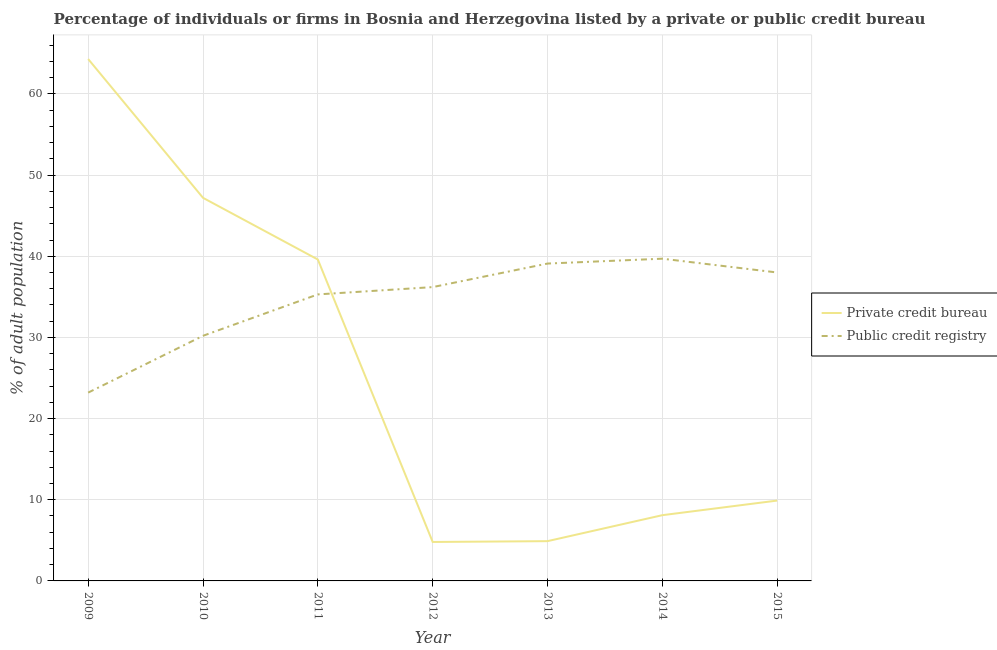How many different coloured lines are there?
Offer a terse response. 2. Does the line corresponding to percentage of firms listed by public credit bureau intersect with the line corresponding to percentage of firms listed by private credit bureau?
Offer a very short reply. Yes. What is the percentage of firms listed by private credit bureau in 2011?
Give a very brief answer. 39.6. Across all years, what is the maximum percentage of firms listed by public credit bureau?
Your answer should be very brief. 39.7. Across all years, what is the minimum percentage of firms listed by private credit bureau?
Your response must be concise. 4.8. In which year was the percentage of firms listed by private credit bureau minimum?
Your response must be concise. 2012. What is the total percentage of firms listed by public credit bureau in the graph?
Provide a succinct answer. 241.7. What is the difference between the percentage of firms listed by public credit bureau in 2009 and that in 2014?
Your response must be concise. -16.5. What is the difference between the percentage of firms listed by private credit bureau in 2015 and the percentage of firms listed by public credit bureau in 2012?
Provide a succinct answer. -26.3. What is the average percentage of firms listed by private credit bureau per year?
Provide a succinct answer. 25.54. In the year 2013, what is the difference between the percentage of firms listed by private credit bureau and percentage of firms listed by public credit bureau?
Keep it short and to the point. -34.2. In how many years, is the percentage of firms listed by public credit bureau greater than 8 %?
Keep it short and to the point. 7. What is the ratio of the percentage of firms listed by public credit bureau in 2010 to that in 2014?
Your response must be concise. 0.76. Is the percentage of firms listed by private credit bureau in 2009 less than that in 2011?
Ensure brevity in your answer.  No. Is the difference between the percentage of firms listed by private credit bureau in 2010 and 2011 greater than the difference between the percentage of firms listed by public credit bureau in 2010 and 2011?
Offer a terse response. Yes. What is the difference between the highest and the second highest percentage of firms listed by private credit bureau?
Give a very brief answer. 17.1. What is the difference between the highest and the lowest percentage of firms listed by public credit bureau?
Offer a terse response. 16.5. Is the percentage of firms listed by private credit bureau strictly greater than the percentage of firms listed by public credit bureau over the years?
Give a very brief answer. No. Is the percentage of firms listed by public credit bureau strictly less than the percentage of firms listed by private credit bureau over the years?
Give a very brief answer. No. How many years are there in the graph?
Give a very brief answer. 7. Are the values on the major ticks of Y-axis written in scientific E-notation?
Ensure brevity in your answer.  No. Does the graph contain any zero values?
Make the answer very short. No. Does the graph contain grids?
Your response must be concise. Yes. Where does the legend appear in the graph?
Your response must be concise. Center right. What is the title of the graph?
Provide a short and direct response. Percentage of individuals or firms in Bosnia and Herzegovina listed by a private or public credit bureau. What is the label or title of the X-axis?
Provide a succinct answer. Year. What is the label or title of the Y-axis?
Offer a very short reply. % of adult population. What is the % of adult population of Private credit bureau in 2009?
Offer a terse response. 64.3. What is the % of adult population of Public credit registry in 2009?
Provide a short and direct response. 23.2. What is the % of adult population in Private credit bureau in 2010?
Offer a terse response. 47.2. What is the % of adult population of Public credit registry in 2010?
Your answer should be compact. 30.2. What is the % of adult population of Private credit bureau in 2011?
Provide a short and direct response. 39.6. What is the % of adult population in Public credit registry in 2011?
Ensure brevity in your answer.  35.3. What is the % of adult population of Public credit registry in 2012?
Offer a very short reply. 36.2. What is the % of adult population of Public credit registry in 2013?
Offer a very short reply. 39.1. What is the % of adult population in Private credit bureau in 2014?
Provide a short and direct response. 8.1. What is the % of adult population of Public credit registry in 2014?
Make the answer very short. 39.7. What is the % of adult population of Private credit bureau in 2015?
Provide a succinct answer. 9.9. What is the % of adult population of Public credit registry in 2015?
Provide a short and direct response. 38. Across all years, what is the maximum % of adult population in Private credit bureau?
Your response must be concise. 64.3. Across all years, what is the maximum % of adult population of Public credit registry?
Your response must be concise. 39.7. Across all years, what is the minimum % of adult population of Public credit registry?
Keep it short and to the point. 23.2. What is the total % of adult population in Private credit bureau in the graph?
Offer a very short reply. 178.8. What is the total % of adult population in Public credit registry in the graph?
Offer a terse response. 241.7. What is the difference between the % of adult population in Private credit bureau in 2009 and that in 2011?
Provide a succinct answer. 24.7. What is the difference between the % of adult population in Private credit bureau in 2009 and that in 2012?
Give a very brief answer. 59.5. What is the difference between the % of adult population in Private credit bureau in 2009 and that in 2013?
Provide a short and direct response. 59.4. What is the difference between the % of adult population of Public credit registry in 2009 and that in 2013?
Provide a succinct answer. -15.9. What is the difference between the % of adult population in Private credit bureau in 2009 and that in 2014?
Your answer should be compact. 56.2. What is the difference between the % of adult population of Public credit registry in 2009 and that in 2014?
Your response must be concise. -16.5. What is the difference between the % of adult population in Private credit bureau in 2009 and that in 2015?
Offer a very short reply. 54.4. What is the difference between the % of adult population in Public credit registry in 2009 and that in 2015?
Offer a very short reply. -14.8. What is the difference between the % of adult population of Private credit bureau in 2010 and that in 2012?
Your answer should be very brief. 42.4. What is the difference between the % of adult population of Public credit registry in 2010 and that in 2012?
Offer a very short reply. -6. What is the difference between the % of adult population in Private credit bureau in 2010 and that in 2013?
Provide a succinct answer. 42.3. What is the difference between the % of adult population of Private credit bureau in 2010 and that in 2014?
Your response must be concise. 39.1. What is the difference between the % of adult population in Public credit registry in 2010 and that in 2014?
Provide a short and direct response. -9.5. What is the difference between the % of adult population of Private credit bureau in 2010 and that in 2015?
Ensure brevity in your answer.  37.3. What is the difference between the % of adult population of Public credit registry in 2010 and that in 2015?
Your response must be concise. -7.8. What is the difference between the % of adult population of Private credit bureau in 2011 and that in 2012?
Offer a very short reply. 34.8. What is the difference between the % of adult population of Private credit bureau in 2011 and that in 2013?
Your answer should be very brief. 34.7. What is the difference between the % of adult population of Private credit bureau in 2011 and that in 2014?
Provide a succinct answer. 31.5. What is the difference between the % of adult population of Private credit bureau in 2011 and that in 2015?
Give a very brief answer. 29.7. What is the difference between the % of adult population in Public credit registry in 2012 and that in 2013?
Provide a short and direct response. -2.9. What is the difference between the % of adult population of Private credit bureau in 2012 and that in 2014?
Keep it short and to the point. -3.3. What is the difference between the % of adult population in Public credit registry in 2012 and that in 2014?
Your answer should be compact. -3.5. What is the difference between the % of adult population in Private credit bureau in 2012 and that in 2015?
Provide a succinct answer. -5.1. What is the difference between the % of adult population in Public credit registry in 2012 and that in 2015?
Offer a terse response. -1.8. What is the difference between the % of adult population in Private credit bureau in 2013 and that in 2014?
Offer a terse response. -3.2. What is the difference between the % of adult population of Public credit registry in 2013 and that in 2015?
Ensure brevity in your answer.  1.1. What is the difference between the % of adult population in Private credit bureau in 2014 and that in 2015?
Offer a terse response. -1.8. What is the difference between the % of adult population in Private credit bureau in 2009 and the % of adult population in Public credit registry in 2010?
Provide a succinct answer. 34.1. What is the difference between the % of adult population of Private credit bureau in 2009 and the % of adult population of Public credit registry in 2011?
Keep it short and to the point. 29. What is the difference between the % of adult population of Private credit bureau in 2009 and the % of adult population of Public credit registry in 2012?
Ensure brevity in your answer.  28.1. What is the difference between the % of adult population of Private credit bureau in 2009 and the % of adult population of Public credit registry in 2013?
Your answer should be very brief. 25.2. What is the difference between the % of adult population in Private credit bureau in 2009 and the % of adult population in Public credit registry in 2014?
Offer a very short reply. 24.6. What is the difference between the % of adult population in Private credit bureau in 2009 and the % of adult population in Public credit registry in 2015?
Your answer should be compact. 26.3. What is the difference between the % of adult population in Private credit bureau in 2010 and the % of adult population in Public credit registry in 2011?
Keep it short and to the point. 11.9. What is the difference between the % of adult population in Private credit bureau in 2010 and the % of adult population in Public credit registry in 2012?
Make the answer very short. 11. What is the difference between the % of adult population of Private credit bureau in 2010 and the % of adult population of Public credit registry in 2013?
Ensure brevity in your answer.  8.1. What is the difference between the % of adult population of Private credit bureau in 2010 and the % of adult population of Public credit registry in 2014?
Keep it short and to the point. 7.5. What is the difference between the % of adult population of Private credit bureau in 2010 and the % of adult population of Public credit registry in 2015?
Provide a short and direct response. 9.2. What is the difference between the % of adult population of Private credit bureau in 2011 and the % of adult population of Public credit registry in 2012?
Your answer should be compact. 3.4. What is the difference between the % of adult population of Private credit bureau in 2012 and the % of adult population of Public credit registry in 2013?
Offer a very short reply. -34.3. What is the difference between the % of adult population of Private credit bureau in 2012 and the % of adult population of Public credit registry in 2014?
Keep it short and to the point. -34.9. What is the difference between the % of adult population in Private credit bureau in 2012 and the % of adult population in Public credit registry in 2015?
Keep it short and to the point. -33.2. What is the difference between the % of adult population in Private credit bureau in 2013 and the % of adult population in Public credit registry in 2014?
Your answer should be very brief. -34.8. What is the difference between the % of adult population of Private credit bureau in 2013 and the % of adult population of Public credit registry in 2015?
Make the answer very short. -33.1. What is the difference between the % of adult population in Private credit bureau in 2014 and the % of adult population in Public credit registry in 2015?
Keep it short and to the point. -29.9. What is the average % of adult population in Private credit bureau per year?
Offer a very short reply. 25.54. What is the average % of adult population in Public credit registry per year?
Your answer should be compact. 34.53. In the year 2009, what is the difference between the % of adult population of Private credit bureau and % of adult population of Public credit registry?
Your answer should be compact. 41.1. In the year 2011, what is the difference between the % of adult population of Private credit bureau and % of adult population of Public credit registry?
Offer a very short reply. 4.3. In the year 2012, what is the difference between the % of adult population in Private credit bureau and % of adult population in Public credit registry?
Give a very brief answer. -31.4. In the year 2013, what is the difference between the % of adult population of Private credit bureau and % of adult population of Public credit registry?
Make the answer very short. -34.2. In the year 2014, what is the difference between the % of adult population in Private credit bureau and % of adult population in Public credit registry?
Your answer should be very brief. -31.6. In the year 2015, what is the difference between the % of adult population of Private credit bureau and % of adult population of Public credit registry?
Your answer should be very brief. -28.1. What is the ratio of the % of adult population of Private credit bureau in 2009 to that in 2010?
Offer a terse response. 1.36. What is the ratio of the % of adult population of Public credit registry in 2009 to that in 2010?
Provide a short and direct response. 0.77. What is the ratio of the % of adult population in Private credit bureau in 2009 to that in 2011?
Provide a succinct answer. 1.62. What is the ratio of the % of adult population in Public credit registry in 2009 to that in 2011?
Keep it short and to the point. 0.66. What is the ratio of the % of adult population in Private credit bureau in 2009 to that in 2012?
Offer a very short reply. 13.4. What is the ratio of the % of adult population of Public credit registry in 2009 to that in 2012?
Make the answer very short. 0.64. What is the ratio of the % of adult population of Private credit bureau in 2009 to that in 2013?
Offer a very short reply. 13.12. What is the ratio of the % of adult population of Public credit registry in 2009 to that in 2013?
Offer a very short reply. 0.59. What is the ratio of the % of adult population in Private credit bureau in 2009 to that in 2014?
Keep it short and to the point. 7.94. What is the ratio of the % of adult population of Public credit registry in 2009 to that in 2014?
Provide a short and direct response. 0.58. What is the ratio of the % of adult population of Private credit bureau in 2009 to that in 2015?
Provide a short and direct response. 6.49. What is the ratio of the % of adult population of Public credit registry in 2009 to that in 2015?
Offer a very short reply. 0.61. What is the ratio of the % of adult population in Private credit bureau in 2010 to that in 2011?
Provide a succinct answer. 1.19. What is the ratio of the % of adult population in Public credit registry in 2010 to that in 2011?
Provide a short and direct response. 0.86. What is the ratio of the % of adult population in Private credit bureau in 2010 to that in 2012?
Make the answer very short. 9.83. What is the ratio of the % of adult population in Public credit registry in 2010 to that in 2012?
Give a very brief answer. 0.83. What is the ratio of the % of adult population of Private credit bureau in 2010 to that in 2013?
Offer a terse response. 9.63. What is the ratio of the % of adult population in Public credit registry in 2010 to that in 2013?
Your response must be concise. 0.77. What is the ratio of the % of adult population of Private credit bureau in 2010 to that in 2014?
Ensure brevity in your answer.  5.83. What is the ratio of the % of adult population in Public credit registry in 2010 to that in 2014?
Offer a terse response. 0.76. What is the ratio of the % of adult population in Private credit bureau in 2010 to that in 2015?
Give a very brief answer. 4.77. What is the ratio of the % of adult population of Public credit registry in 2010 to that in 2015?
Provide a succinct answer. 0.79. What is the ratio of the % of adult population in Private credit bureau in 2011 to that in 2012?
Ensure brevity in your answer.  8.25. What is the ratio of the % of adult population of Public credit registry in 2011 to that in 2012?
Keep it short and to the point. 0.98. What is the ratio of the % of adult population in Private credit bureau in 2011 to that in 2013?
Keep it short and to the point. 8.08. What is the ratio of the % of adult population of Public credit registry in 2011 to that in 2013?
Offer a very short reply. 0.9. What is the ratio of the % of adult population in Private credit bureau in 2011 to that in 2014?
Provide a short and direct response. 4.89. What is the ratio of the % of adult population in Public credit registry in 2011 to that in 2014?
Make the answer very short. 0.89. What is the ratio of the % of adult population of Private credit bureau in 2011 to that in 2015?
Your answer should be compact. 4. What is the ratio of the % of adult population in Public credit registry in 2011 to that in 2015?
Provide a succinct answer. 0.93. What is the ratio of the % of adult population of Private credit bureau in 2012 to that in 2013?
Make the answer very short. 0.98. What is the ratio of the % of adult population of Public credit registry in 2012 to that in 2013?
Provide a succinct answer. 0.93. What is the ratio of the % of adult population of Private credit bureau in 2012 to that in 2014?
Your answer should be compact. 0.59. What is the ratio of the % of adult population of Public credit registry in 2012 to that in 2014?
Give a very brief answer. 0.91. What is the ratio of the % of adult population of Private credit bureau in 2012 to that in 2015?
Your response must be concise. 0.48. What is the ratio of the % of adult population in Public credit registry in 2012 to that in 2015?
Make the answer very short. 0.95. What is the ratio of the % of adult population in Private credit bureau in 2013 to that in 2014?
Your answer should be compact. 0.6. What is the ratio of the % of adult population in Public credit registry in 2013 to that in 2014?
Offer a very short reply. 0.98. What is the ratio of the % of adult population in Private credit bureau in 2013 to that in 2015?
Make the answer very short. 0.49. What is the ratio of the % of adult population of Public credit registry in 2013 to that in 2015?
Your answer should be very brief. 1.03. What is the ratio of the % of adult population of Private credit bureau in 2014 to that in 2015?
Provide a short and direct response. 0.82. What is the ratio of the % of adult population of Public credit registry in 2014 to that in 2015?
Provide a short and direct response. 1.04. What is the difference between the highest and the second highest % of adult population in Private credit bureau?
Keep it short and to the point. 17.1. What is the difference between the highest and the lowest % of adult population of Private credit bureau?
Provide a succinct answer. 59.5. What is the difference between the highest and the lowest % of adult population of Public credit registry?
Give a very brief answer. 16.5. 